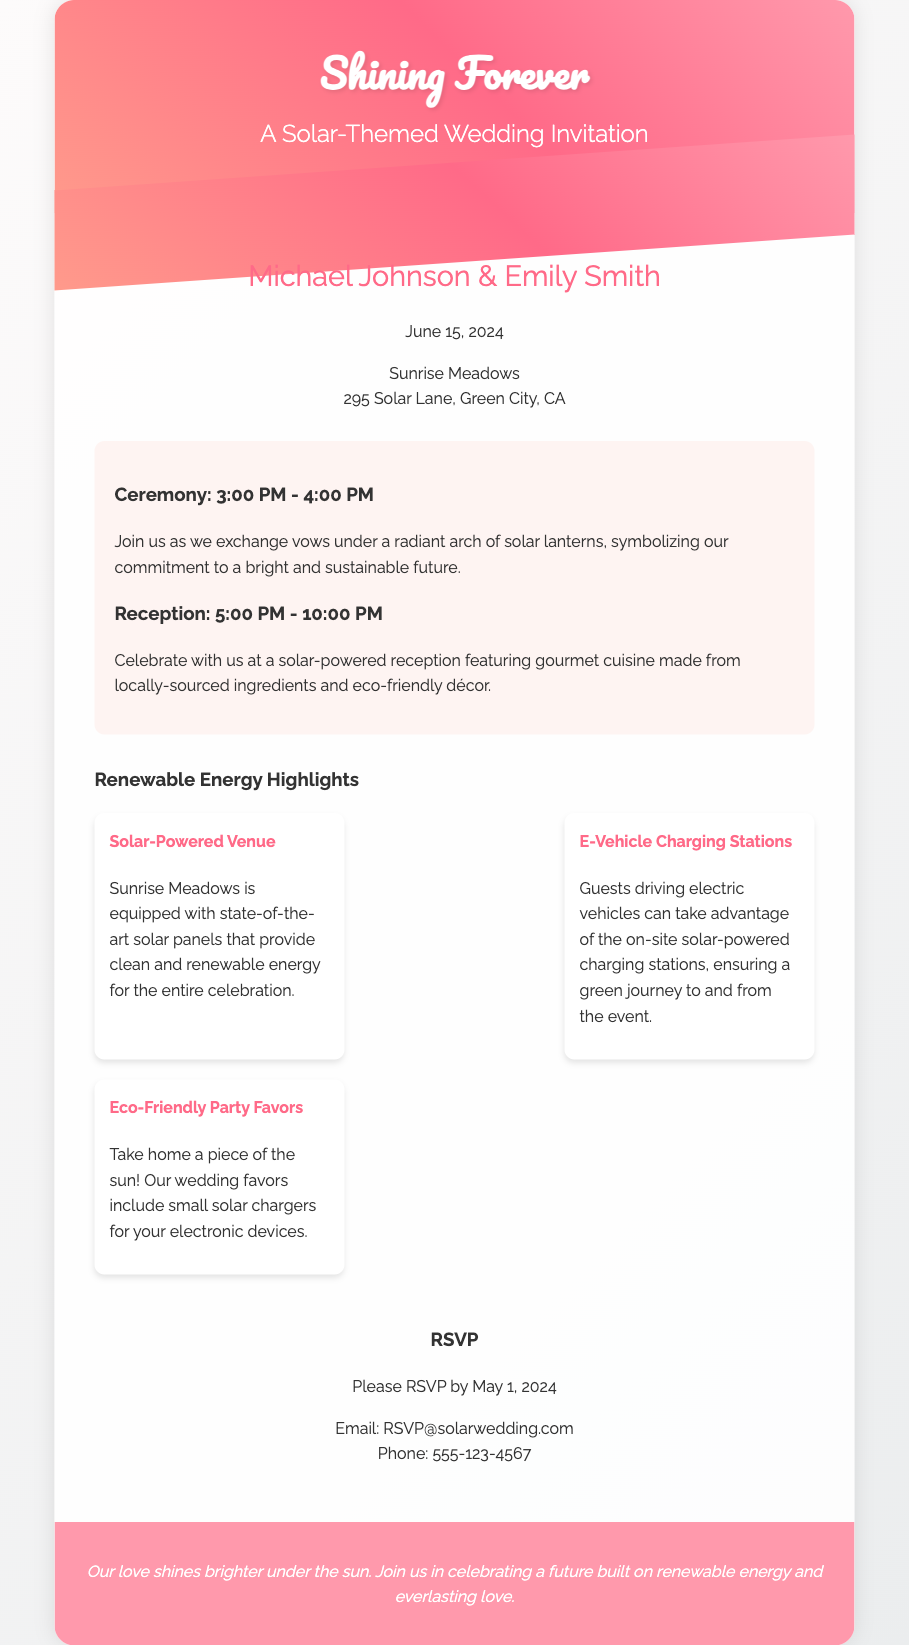What are the names of the couple? The names of the couple are mentioned prominently in the document under the "names" section.
Answer: Michael Johnson & Emily Smith What is the wedding date? The wedding date is specified in the "date-venue" section of the invitation.
Answer: June 15, 2024 Where is the venue located? The venue location is provided in the "date-venue" section of the document.
Answer: Sunrise Meadows, 295 Solar Lane, Green City, CA What time does the ceremony start? The start time for the ceremony is indicated in the "details" section of the invitation.
Answer: 3:00 PM What type of cuisine will be served at the reception? The type of cuisine is described in the reception details within the "details" section.
Answer: Gourmet cuisine made from locally-sourced ingredients What is a highlight about the venue? The highlight regarding the venue's features can be found in the "Renewable Energy Highlights" section.
Answer: Solar-Powered Venue What is one of the eco-friendly party favors? The eco-friendly party favors are listed in the "highlights" section of the document.
Answer: Small solar chargers What is the RSVP deadline? The RSVP deadline is clearly stated in the "rsvp" section of the invitation.
Answer: May 1, 2024 What email can guests use to RSVP? The contact method for RSVPs is included in the "rsvp" section of the document.
Answer: RSVP@solarwedding.com 